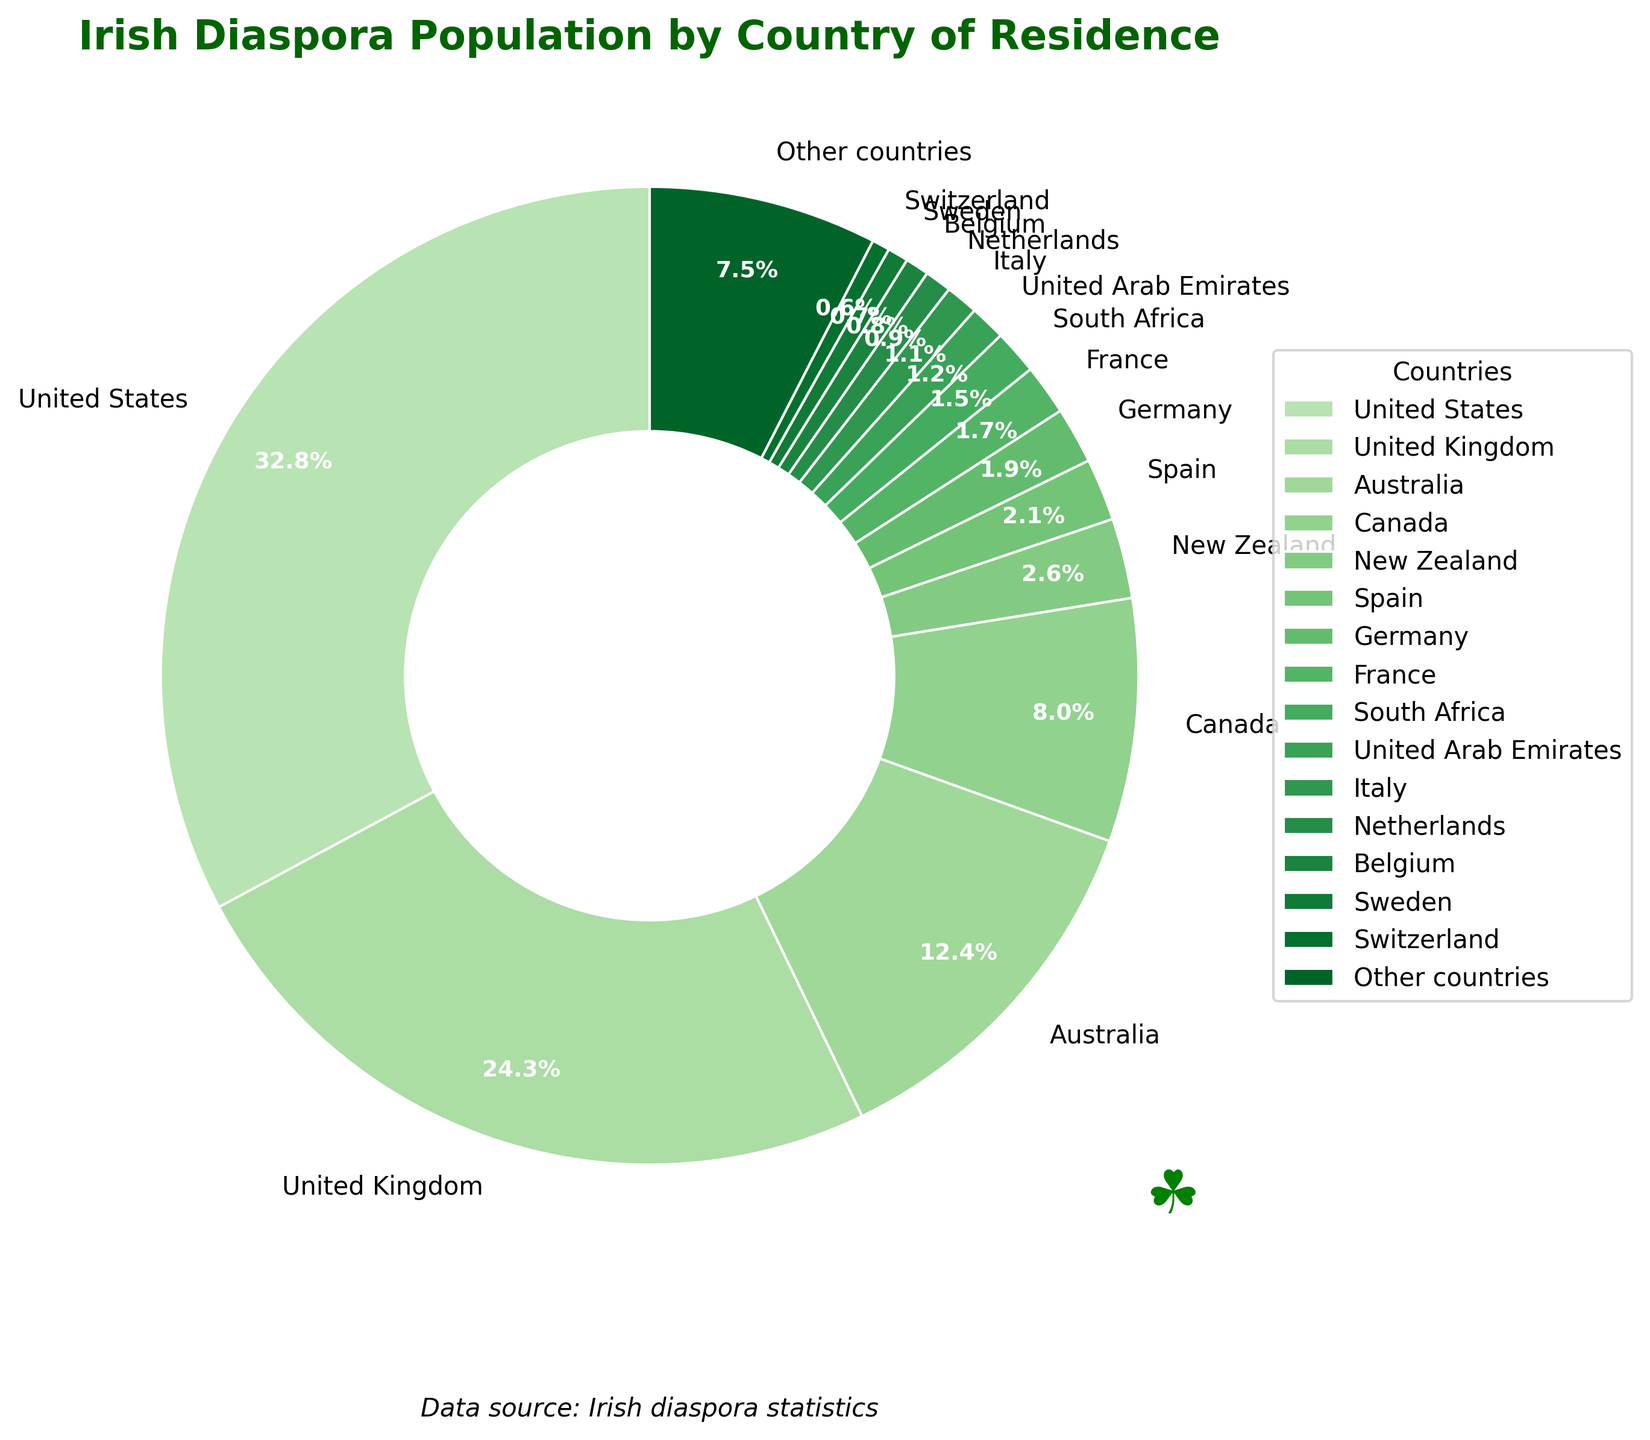What is the percentage of the Irish diaspora living in the United States? The pie chart shows the percentage breakdown of Irish diaspora populations by country. From the chart, the United States segment is labeled with a percentage.
Answer: 33.5% Which country has a higher percentage of Irish diaspora: Canada or Australia? From the pie chart, observe the labeled percentages for both Canada and Australia. Compare the two values, where Australia's percentage is 12.6% and Canada's is 8.2%.
Answer: Australia What is the combined percentage of the Irish diaspora living in Spain, Germany, and France? Identify the percentages for Spain (2.1%), Germany (1.9%), and France (1.7%) from the chart. Add these values together: 2.1% + 1.9% + 1.7% = 5.7%.
Answer: 5.7% What is the difference in percentage between the Irish diaspora populations in the United Kingdom and the United States? Find the percentages for the United Kingdom (24.8%) and the United States (33.5%) from the chart. Calculate the difference: 33.5% - 24.8% = 8.7%.
Answer: 8.7% Which three countries have the smallest percentages of the Irish diaspora? By examining the pie chart, note the countries with the smallest labeled percentages. These are Switzerland (0.6%), Sweden (0.7%), and Belgium (0.8%).
Answer: Switzerland, Sweden, Belgium What is the combined percentage of the Irish diaspora in the United States, the United Kingdom, and Australia? Note the percentages for the United States (33.5%), the United Kingdom (24.8%), and Australia (12.6%) from the chart. Add them together: 33.5% + 24.8% + 12.6% = 70.9%.
Answer: 70.9% Does the Irish diaspora in New Zealand represent a larger percentage than in Spain? Refer to the pie chart for the percentages: New Zealand (2.7%) and Spain (2.1%). Compare the two values and see that New Zealand’s percentage is larger.
Answer: Yes How much more significant is the Irish diaspora in Canada compared to the United Arab Emirates? The pie chart shows Canada with 8.2% and the United Arab Emirates with 1.2%. Subtract the smaller percentage from the larger one: 8.2% - 1.2% = 7.0%.
Answer: 7.0% Among the countries listed, which one has the highest percentage of the Irish diaspora? Observe the pie chart and identify the segment with the highest percentage, which is labeled as the United States with 33.5%.
Answer: United States 